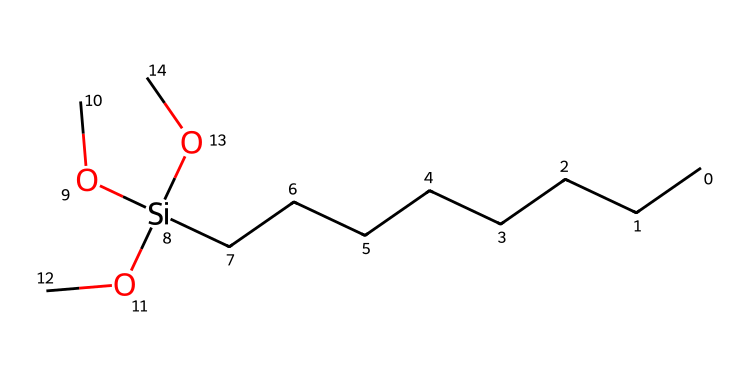What is the total number of carbon atoms in this silane? Each 'C' in the SMILES indicates a carbon atom. Counting from the left, there are 8 carbon atoms represented by the 'CCCCCCCC' part.
Answer: eight How many silicon atoms are present in this chemical structure? The '[Si]' notation clearly indicates the presence of one silicon atom.
Answer: one What functional groups are attached to the silicon atom in this structure? The 'OC' notation signifies three methoxy (-OCH3) groups attached to the silicon atom, thus representing the functional groups.
Answer: methoxy What is the overall formula for this organosilane? By combining the atoms represented, the structure can be represented as C8H18O3Si, considering 8 carbons, 18 hydrogens from branched hydrogens, and 3 oxygens from methoxy groups.
Answer: C8H18O3Si How many ether linkages are found in this compound? Each 'OC' represents a methoxy group, thus indicating three methoxy groups, so there are three ether linkages.
Answer: three What characteristic of this silane contributes to its non-stick properties? The presence of multiple methoxy groups provides a smooth and hydrophobic surface, contributing to non-stick characteristics.
Answer: methoxy groups What type of silane is represented by this structure? The structure indicates that it is a trialkoxysilane due to the presence of three alkoxy groups attached to the silicon.
Answer: trialkoxysilane 